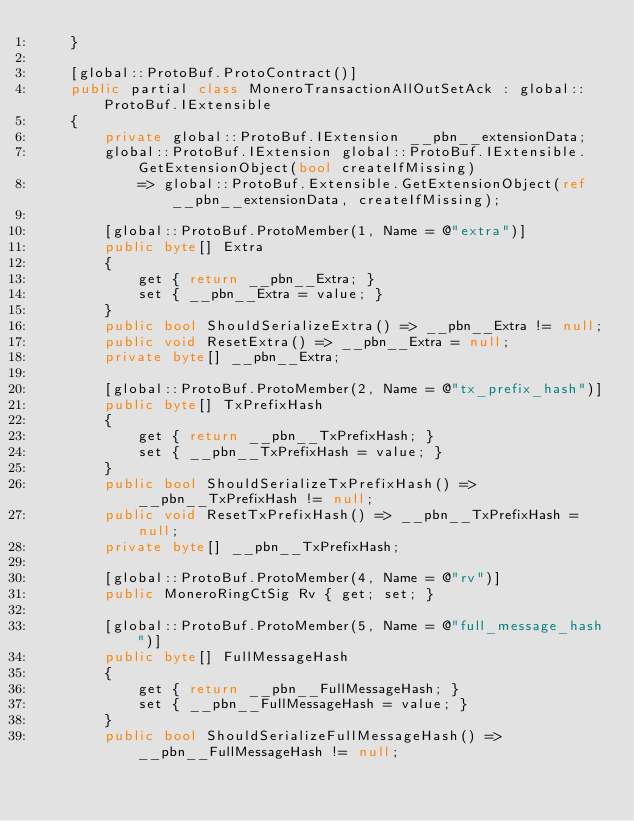<code> <loc_0><loc_0><loc_500><loc_500><_C#_>    }

    [global::ProtoBuf.ProtoContract()]
    public partial class MoneroTransactionAllOutSetAck : global::ProtoBuf.IExtensible
    {
        private global::ProtoBuf.IExtension __pbn__extensionData;
        global::ProtoBuf.IExtension global::ProtoBuf.IExtensible.GetExtensionObject(bool createIfMissing)
            => global::ProtoBuf.Extensible.GetExtensionObject(ref __pbn__extensionData, createIfMissing);

        [global::ProtoBuf.ProtoMember(1, Name = @"extra")]
        public byte[] Extra
        {
            get { return __pbn__Extra; }
            set { __pbn__Extra = value; }
        }
        public bool ShouldSerializeExtra() => __pbn__Extra != null;
        public void ResetExtra() => __pbn__Extra = null;
        private byte[] __pbn__Extra;

        [global::ProtoBuf.ProtoMember(2, Name = @"tx_prefix_hash")]
        public byte[] TxPrefixHash
        {
            get { return __pbn__TxPrefixHash; }
            set { __pbn__TxPrefixHash = value; }
        }
        public bool ShouldSerializeTxPrefixHash() => __pbn__TxPrefixHash != null;
        public void ResetTxPrefixHash() => __pbn__TxPrefixHash = null;
        private byte[] __pbn__TxPrefixHash;

        [global::ProtoBuf.ProtoMember(4, Name = @"rv")]
        public MoneroRingCtSig Rv { get; set; }

        [global::ProtoBuf.ProtoMember(5, Name = @"full_message_hash")]
        public byte[] FullMessageHash
        {
            get { return __pbn__FullMessageHash; }
            set { __pbn__FullMessageHash = value; }
        }
        public bool ShouldSerializeFullMessageHash() => __pbn__FullMessageHash != null;</code> 